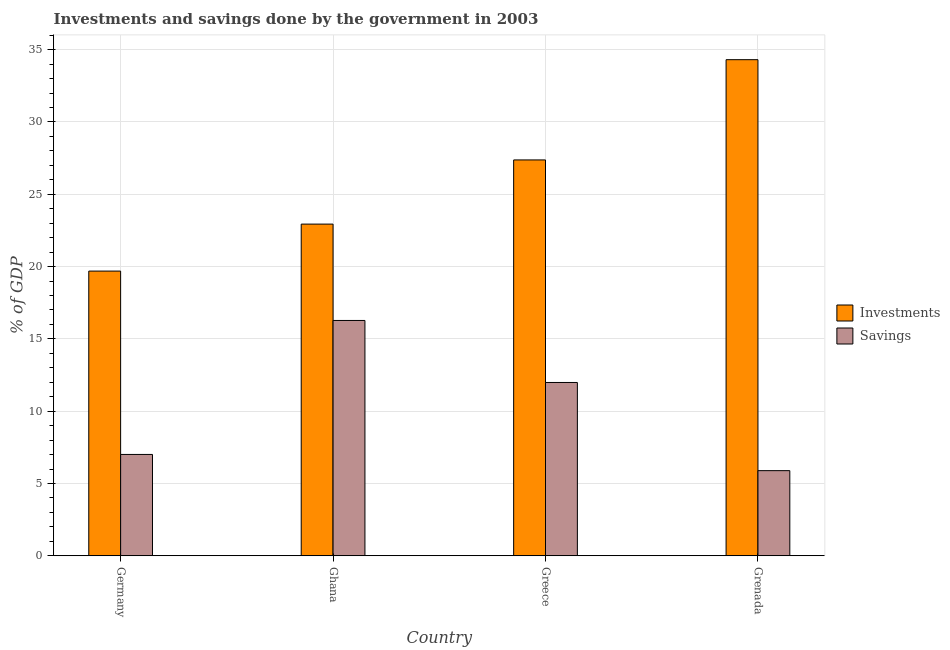Are the number of bars on each tick of the X-axis equal?
Make the answer very short. Yes. How many bars are there on the 1st tick from the left?
Your answer should be very brief. 2. What is the label of the 4th group of bars from the left?
Provide a short and direct response. Grenada. What is the savings of government in Greece?
Make the answer very short. 11.98. Across all countries, what is the maximum savings of government?
Ensure brevity in your answer.  16.27. Across all countries, what is the minimum savings of government?
Provide a short and direct response. 5.89. In which country was the savings of government maximum?
Your response must be concise. Ghana. In which country was the investments of government minimum?
Keep it short and to the point. Germany. What is the total savings of government in the graph?
Give a very brief answer. 41.15. What is the difference between the investments of government in Greece and that in Grenada?
Make the answer very short. -6.93. What is the difference between the investments of government in Grenada and the savings of government in Germany?
Your answer should be compact. 27.3. What is the average savings of government per country?
Your response must be concise. 10.29. What is the difference between the investments of government and savings of government in Greece?
Your answer should be very brief. 15.39. In how many countries, is the savings of government greater than 18 %?
Ensure brevity in your answer.  0. What is the ratio of the savings of government in Ghana to that in Grenada?
Give a very brief answer. 2.76. What is the difference between the highest and the second highest savings of government?
Offer a very short reply. 4.29. What is the difference between the highest and the lowest investments of government?
Your answer should be very brief. 14.62. In how many countries, is the savings of government greater than the average savings of government taken over all countries?
Provide a short and direct response. 2. What does the 2nd bar from the left in Grenada represents?
Your answer should be compact. Savings. What does the 2nd bar from the right in Ghana represents?
Give a very brief answer. Investments. Are all the bars in the graph horizontal?
Your answer should be very brief. No. How many countries are there in the graph?
Provide a succinct answer. 4. What is the difference between two consecutive major ticks on the Y-axis?
Keep it short and to the point. 5. Does the graph contain grids?
Offer a very short reply. Yes. How are the legend labels stacked?
Your answer should be very brief. Vertical. What is the title of the graph?
Make the answer very short. Investments and savings done by the government in 2003. Does "Automatic Teller Machines" appear as one of the legend labels in the graph?
Provide a short and direct response. No. What is the label or title of the X-axis?
Make the answer very short. Country. What is the label or title of the Y-axis?
Make the answer very short. % of GDP. What is the % of GDP in Investments in Germany?
Offer a very short reply. 19.69. What is the % of GDP in Savings in Germany?
Make the answer very short. 7.01. What is the % of GDP of Investments in Ghana?
Your answer should be compact. 22.94. What is the % of GDP in Savings in Ghana?
Provide a short and direct response. 16.27. What is the % of GDP in Investments in Greece?
Offer a terse response. 27.37. What is the % of GDP in Savings in Greece?
Give a very brief answer. 11.98. What is the % of GDP in Investments in Grenada?
Ensure brevity in your answer.  34.31. What is the % of GDP of Savings in Grenada?
Your answer should be very brief. 5.89. Across all countries, what is the maximum % of GDP of Investments?
Offer a very short reply. 34.31. Across all countries, what is the maximum % of GDP in Savings?
Give a very brief answer. 16.27. Across all countries, what is the minimum % of GDP in Investments?
Offer a very short reply. 19.69. Across all countries, what is the minimum % of GDP in Savings?
Ensure brevity in your answer.  5.89. What is the total % of GDP in Investments in the graph?
Provide a short and direct response. 104.31. What is the total % of GDP in Savings in the graph?
Provide a short and direct response. 41.15. What is the difference between the % of GDP in Investments in Germany and that in Ghana?
Make the answer very short. -3.25. What is the difference between the % of GDP of Savings in Germany and that in Ghana?
Give a very brief answer. -9.27. What is the difference between the % of GDP in Investments in Germany and that in Greece?
Offer a terse response. -7.69. What is the difference between the % of GDP of Savings in Germany and that in Greece?
Give a very brief answer. -4.98. What is the difference between the % of GDP in Investments in Germany and that in Grenada?
Keep it short and to the point. -14.62. What is the difference between the % of GDP in Savings in Germany and that in Grenada?
Make the answer very short. 1.12. What is the difference between the % of GDP in Investments in Ghana and that in Greece?
Give a very brief answer. -4.44. What is the difference between the % of GDP of Savings in Ghana and that in Greece?
Give a very brief answer. 4.29. What is the difference between the % of GDP of Investments in Ghana and that in Grenada?
Offer a terse response. -11.37. What is the difference between the % of GDP in Savings in Ghana and that in Grenada?
Offer a terse response. 10.39. What is the difference between the % of GDP of Investments in Greece and that in Grenada?
Offer a terse response. -6.93. What is the difference between the % of GDP of Savings in Greece and that in Grenada?
Provide a short and direct response. 6.1. What is the difference between the % of GDP in Investments in Germany and the % of GDP in Savings in Ghana?
Provide a short and direct response. 3.41. What is the difference between the % of GDP in Investments in Germany and the % of GDP in Savings in Greece?
Your response must be concise. 7.7. What is the difference between the % of GDP of Investments in Germany and the % of GDP of Savings in Grenada?
Make the answer very short. 13.8. What is the difference between the % of GDP of Investments in Ghana and the % of GDP of Savings in Greece?
Make the answer very short. 10.95. What is the difference between the % of GDP of Investments in Ghana and the % of GDP of Savings in Grenada?
Offer a very short reply. 17.05. What is the difference between the % of GDP of Investments in Greece and the % of GDP of Savings in Grenada?
Keep it short and to the point. 21.49. What is the average % of GDP in Investments per country?
Keep it short and to the point. 26.08. What is the average % of GDP in Savings per country?
Make the answer very short. 10.29. What is the difference between the % of GDP in Investments and % of GDP in Savings in Germany?
Make the answer very short. 12.68. What is the difference between the % of GDP in Investments and % of GDP in Savings in Ghana?
Provide a short and direct response. 6.66. What is the difference between the % of GDP in Investments and % of GDP in Savings in Greece?
Offer a very short reply. 15.39. What is the difference between the % of GDP in Investments and % of GDP in Savings in Grenada?
Keep it short and to the point. 28.42. What is the ratio of the % of GDP of Investments in Germany to that in Ghana?
Your response must be concise. 0.86. What is the ratio of the % of GDP of Savings in Germany to that in Ghana?
Make the answer very short. 0.43. What is the ratio of the % of GDP in Investments in Germany to that in Greece?
Ensure brevity in your answer.  0.72. What is the ratio of the % of GDP of Savings in Germany to that in Greece?
Your answer should be very brief. 0.58. What is the ratio of the % of GDP in Investments in Germany to that in Grenada?
Your answer should be compact. 0.57. What is the ratio of the % of GDP of Savings in Germany to that in Grenada?
Offer a terse response. 1.19. What is the ratio of the % of GDP in Investments in Ghana to that in Greece?
Keep it short and to the point. 0.84. What is the ratio of the % of GDP in Savings in Ghana to that in Greece?
Offer a terse response. 1.36. What is the ratio of the % of GDP of Investments in Ghana to that in Grenada?
Provide a succinct answer. 0.67. What is the ratio of the % of GDP of Savings in Ghana to that in Grenada?
Provide a succinct answer. 2.76. What is the ratio of the % of GDP of Investments in Greece to that in Grenada?
Offer a terse response. 0.8. What is the ratio of the % of GDP of Savings in Greece to that in Grenada?
Keep it short and to the point. 2.04. What is the difference between the highest and the second highest % of GDP in Investments?
Give a very brief answer. 6.93. What is the difference between the highest and the second highest % of GDP in Savings?
Offer a terse response. 4.29. What is the difference between the highest and the lowest % of GDP in Investments?
Give a very brief answer. 14.62. What is the difference between the highest and the lowest % of GDP of Savings?
Your response must be concise. 10.39. 